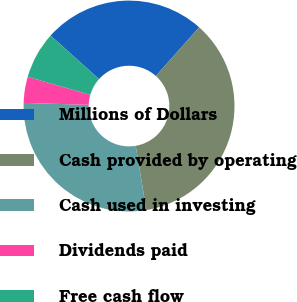<chart> <loc_0><loc_0><loc_500><loc_500><pie_chart><fcel>Millions of Dollars<fcel>Cash provided by operating<fcel>Cash used in investing<fcel>Dividends paid<fcel>Free cash flow<nl><fcel>24.93%<fcel>35.79%<fcel>28.11%<fcel>4.0%<fcel>7.18%<nl></chart> 